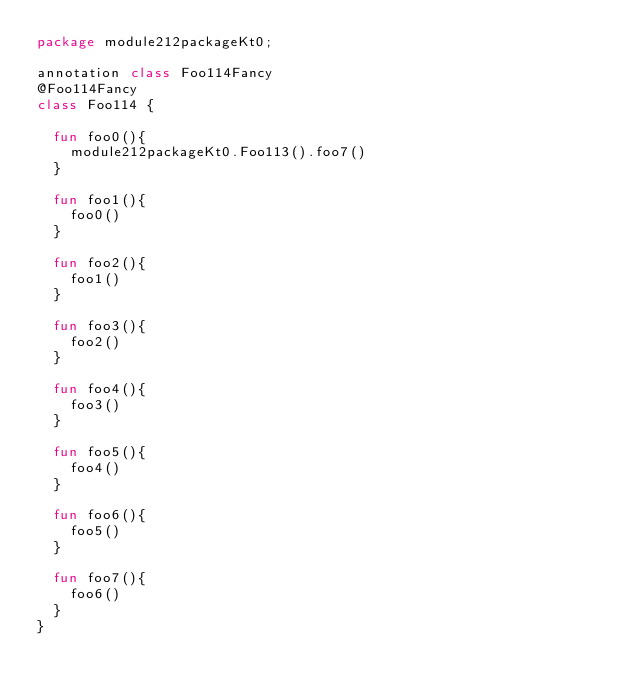<code> <loc_0><loc_0><loc_500><loc_500><_Kotlin_>package module212packageKt0;

annotation class Foo114Fancy
@Foo114Fancy
class Foo114 {

  fun foo0(){
    module212packageKt0.Foo113().foo7()
  }

  fun foo1(){
    foo0()
  }

  fun foo2(){
    foo1()
  }

  fun foo3(){
    foo2()
  }

  fun foo4(){
    foo3()
  }

  fun foo5(){
    foo4()
  }

  fun foo6(){
    foo5()
  }

  fun foo7(){
    foo6()
  }
}</code> 